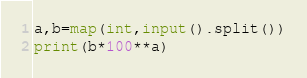<code> <loc_0><loc_0><loc_500><loc_500><_Python_>a,b=map(int,input().split())
print(b*100**a)</code> 